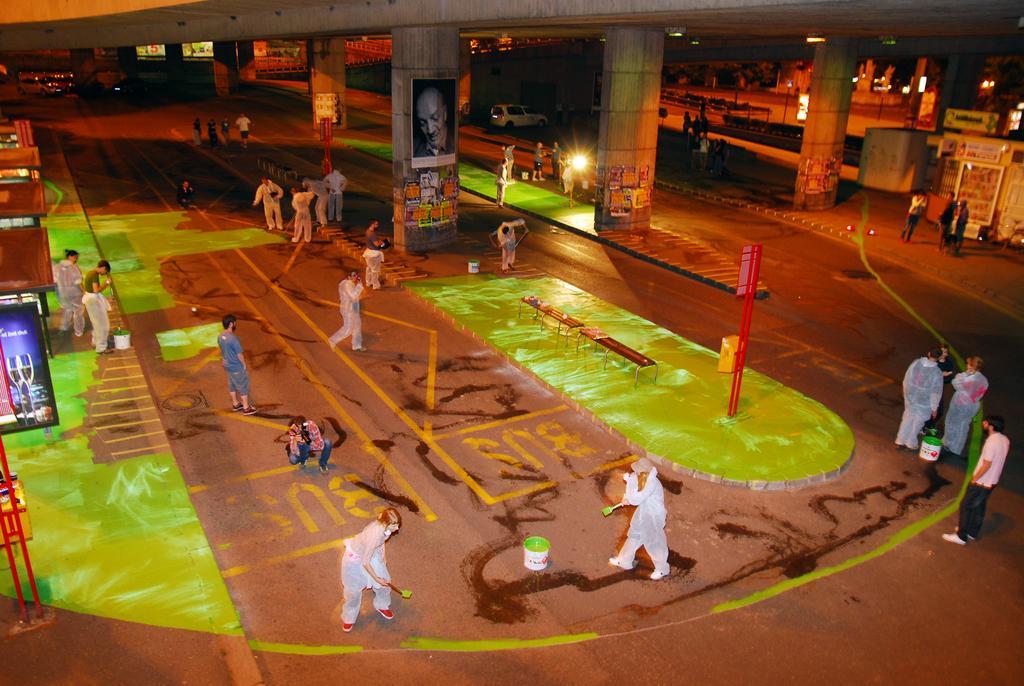Could you give a brief overview of what you see in this image? Here we can see group of people on the road. There are buckets, benches, poles, boards, hoardings, pillars, and vehicles. In the background we can see buildings and lights. 